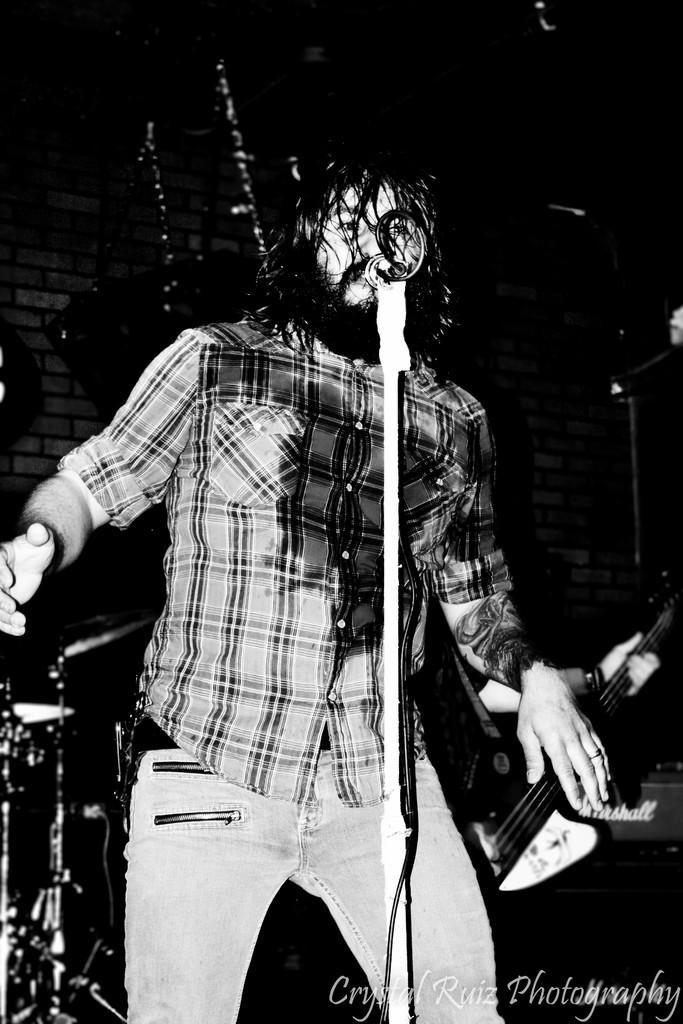In one or two sentences, can you explain what this image depicts? In this picture there is a man who is singing. There is a mic and other musical instruments at the background. There is a guitar. 